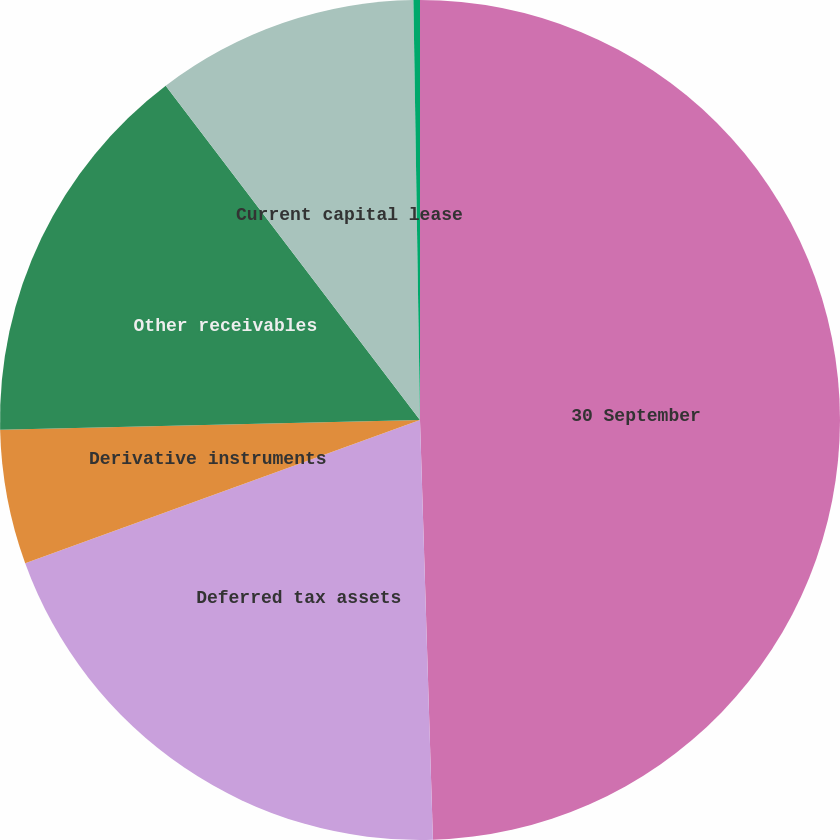Convert chart to OTSL. <chart><loc_0><loc_0><loc_500><loc_500><pie_chart><fcel>30 September<fcel>Deferred tax assets<fcel>Derivative instruments<fcel>Other receivables<fcel>Current capital lease<fcel>Other<nl><fcel>49.51%<fcel>19.95%<fcel>5.17%<fcel>15.02%<fcel>10.1%<fcel>0.25%<nl></chart> 